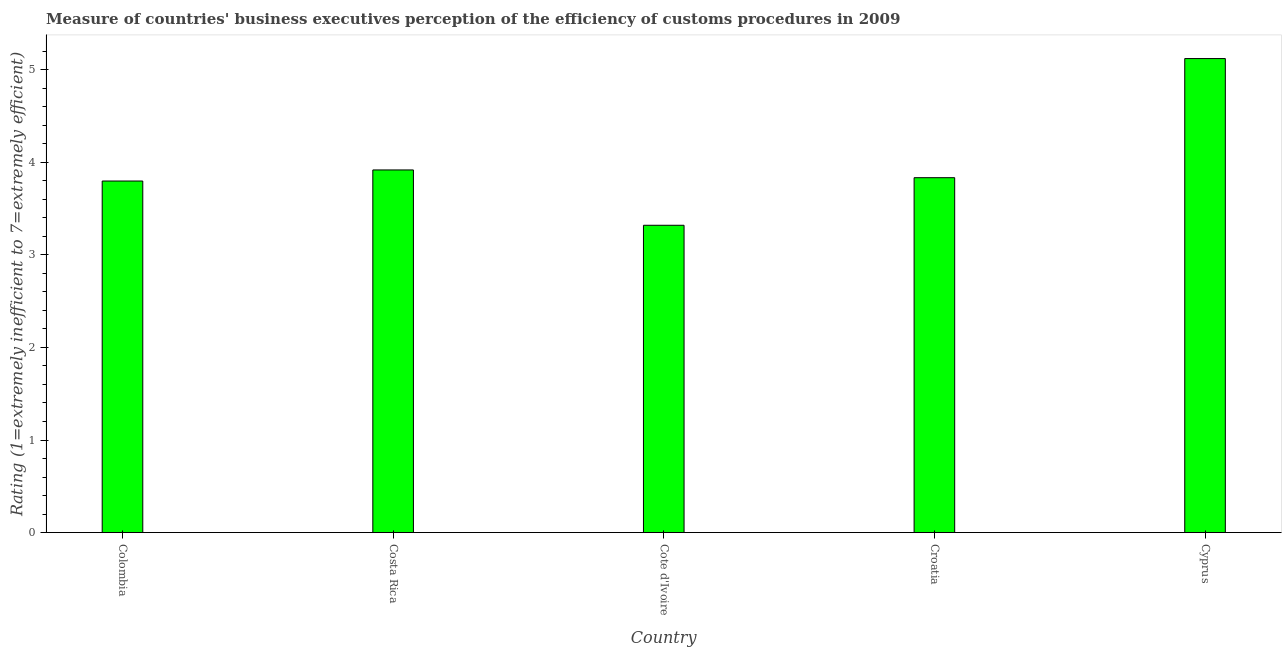Does the graph contain any zero values?
Give a very brief answer. No. Does the graph contain grids?
Make the answer very short. No. What is the title of the graph?
Offer a terse response. Measure of countries' business executives perception of the efficiency of customs procedures in 2009. What is the label or title of the Y-axis?
Your answer should be compact. Rating (1=extremely inefficient to 7=extremely efficient). What is the rating measuring burden of customs procedure in Costa Rica?
Provide a short and direct response. 3.92. Across all countries, what is the maximum rating measuring burden of customs procedure?
Ensure brevity in your answer.  5.12. Across all countries, what is the minimum rating measuring burden of customs procedure?
Offer a very short reply. 3.32. In which country was the rating measuring burden of customs procedure maximum?
Your answer should be compact. Cyprus. In which country was the rating measuring burden of customs procedure minimum?
Your answer should be very brief. Cote d'Ivoire. What is the sum of the rating measuring burden of customs procedure?
Your answer should be compact. 19.99. What is the difference between the rating measuring burden of customs procedure in Croatia and Cyprus?
Your answer should be compact. -1.29. What is the average rating measuring burden of customs procedure per country?
Provide a short and direct response. 4. What is the median rating measuring burden of customs procedure?
Make the answer very short. 3.83. What is the ratio of the rating measuring burden of customs procedure in Colombia to that in Cote d'Ivoire?
Give a very brief answer. 1.14. Is the rating measuring burden of customs procedure in Costa Rica less than that in Cote d'Ivoire?
Ensure brevity in your answer.  No. What is the difference between the highest and the second highest rating measuring burden of customs procedure?
Your answer should be very brief. 1.2. What is the difference between the highest and the lowest rating measuring burden of customs procedure?
Offer a very short reply. 1.8. How many bars are there?
Offer a very short reply. 5. Are all the bars in the graph horizontal?
Provide a short and direct response. No. How many countries are there in the graph?
Offer a very short reply. 5. What is the Rating (1=extremely inefficient to 7=extremely efficient) in Colombia?
Your answer should be very brief. 3.8. What is the Rating (1=extremely inefficient to 7=extremely efficient) in Costa Rica?
Provide a short and direct response. 3.92. What is the Rating (1=extremely inefficient to 7=extremely efficient) of Cote d'Ivoire?
Give a very brief answer. 3.32. What is the Rating (1=extremely inefficient to 7=extremely efficient) of Croatia?
Your answer should be compact. 3.83. What is the Rating (1=extremely inefficient to 7=extremely efficient) in Cyprus?
Keep it short and to the point. 5.12. What is the difference between the Rating (1=extremely inefficient to 7=extremely efficient) in Colombia and Costa Rica?
Offer a very short reply. -0.12. What is the difference between the Rating (1=extremely inefficient to 7=extremely efficient) in Colombia and Cote d'Ivoire?
Give a very brief answer. 0.48. What is the difference between the Rating (1=extremely inefficient to 7=extremely efficient) in Colombia and Croatia?
Provide a short and direct response. -0.04. What is the difference between the Rating (1=extremely inefficient to 7=extremely efficient) in Colombia and Cyprus?
Make the answer very short. -1.32. What is the difference between the Rating (1=extremely inefficient to 7=extremely efficient) in Costa Rica and Cote d'Ivoire?
Give a very brief answer. 0.6. What is the difference between the Rating (1=extremely inefficient to 7=extremely efficient) in Costa Rica and Croatia?
Your answer should be compact. 0.08. What is the difference between the Rating (1=extremely inefficient to 7=extremely efficient) in Costa Rica and Cyprus?
Offer a very short reply. -1.2. What is the difference between the Rating (1=extremely inefficient to 7=extremely efficient) in Cote d'Ivoire and Croatia?
Your response must be concise. -0.51. What is the difference between the Rating (1=extremely inefficient to 7=extremely efficient) in Cote d'Ivoire and Cyprus?
Your response must be concise. -1.8. What is the difference between the Rating (1=extremely inefficient to 7=extremely efficient) in Croatia and Cyprus?
Keep it short and to the point. -1.29. What is the ratio of the Rating (1=extremely inefficient to 7=extremely efficient) in Colombia to that in Costa Rica?
Ensure brevity in your answer.  0.97. What is the ratio of the Rating (1=extremely inefficient to 7=extremely efficient) in Colombia to that in Cote d'Ivoire?
Provide a short and direct response. 1.14. What is the ratio of the Rating (1=extremely inefficient to 7=extremely efficient) in Colombia to that in Cyprus?
Offer a terse response. 0.74. What is the ratio of the Rating (1=extremely inefficient to 7=extremely efficient) in Costa Rica to that in Cote d'Ivoire?
Give a very brief answer. 1.18. What is the ratio of the Rating (1=extremely inefficient to 7=extremely efficient) in Costa Rica to that in Cyprus?
Provide a short and direct response. 0.77. What is the ratio of the Rating (1=extremely inefficient to 7=extremely efficient) in Cote d'Ivoire to that in Croatia?
Ensure brevity in your answer.  0.87. What is the ratio of the Rating (1=extremely inefficient to 7=extremely efficient) in Cote d'Ivoire to that in Cyprus?
Keep it short and to the point. 0.65. What is the ratio of the Rating (1=extremely inefficient to 7=extremely efficient) in Croatia to that in Cyprus?
Your response must be concise. 0.75. 